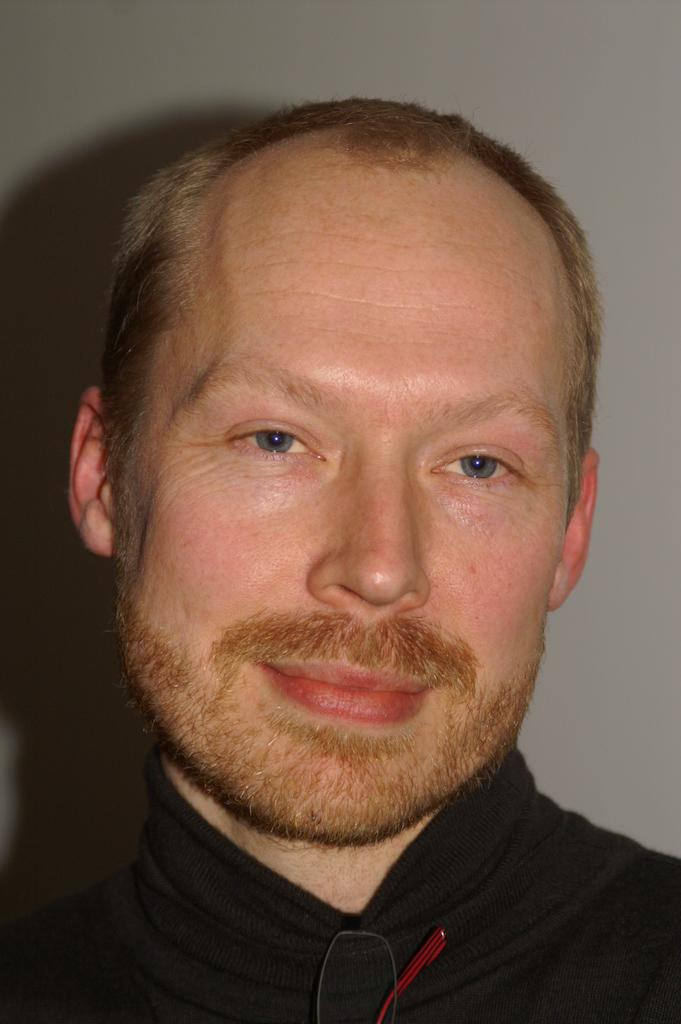Who is present in the image? There is a man in the image. What can be seen in the background of the image? The man's shadow is visible on the wall in the background. What type of canvas is the man painting in the image? There is no canvas present in the image, nor is the man painting; he is simply standing in the image with his shadow visible on the wall. 